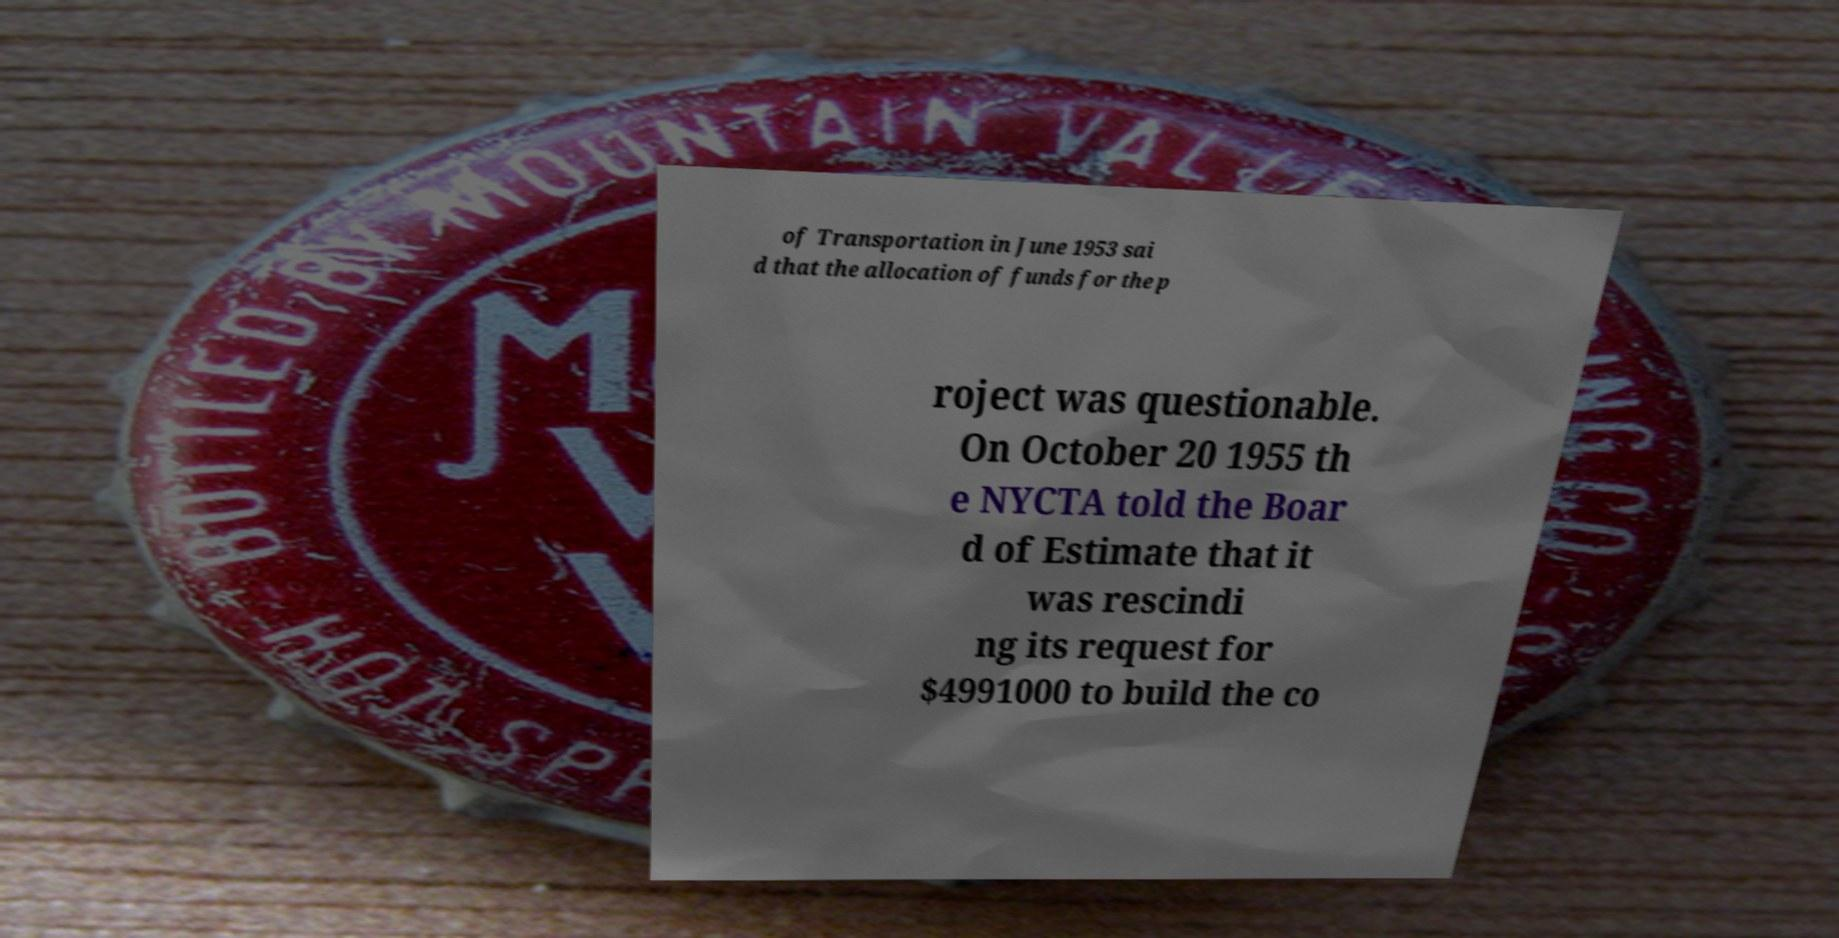Could you assist in decoding the text presented in this image and type it out clearly? of Transportation in June 1953 sai d that the allocation of funds for the p roject was questionable. On October 20 1955 th e NYCTA told the Boar d of Estimate that it was rescindi ng its request for $4991000 to build the co 